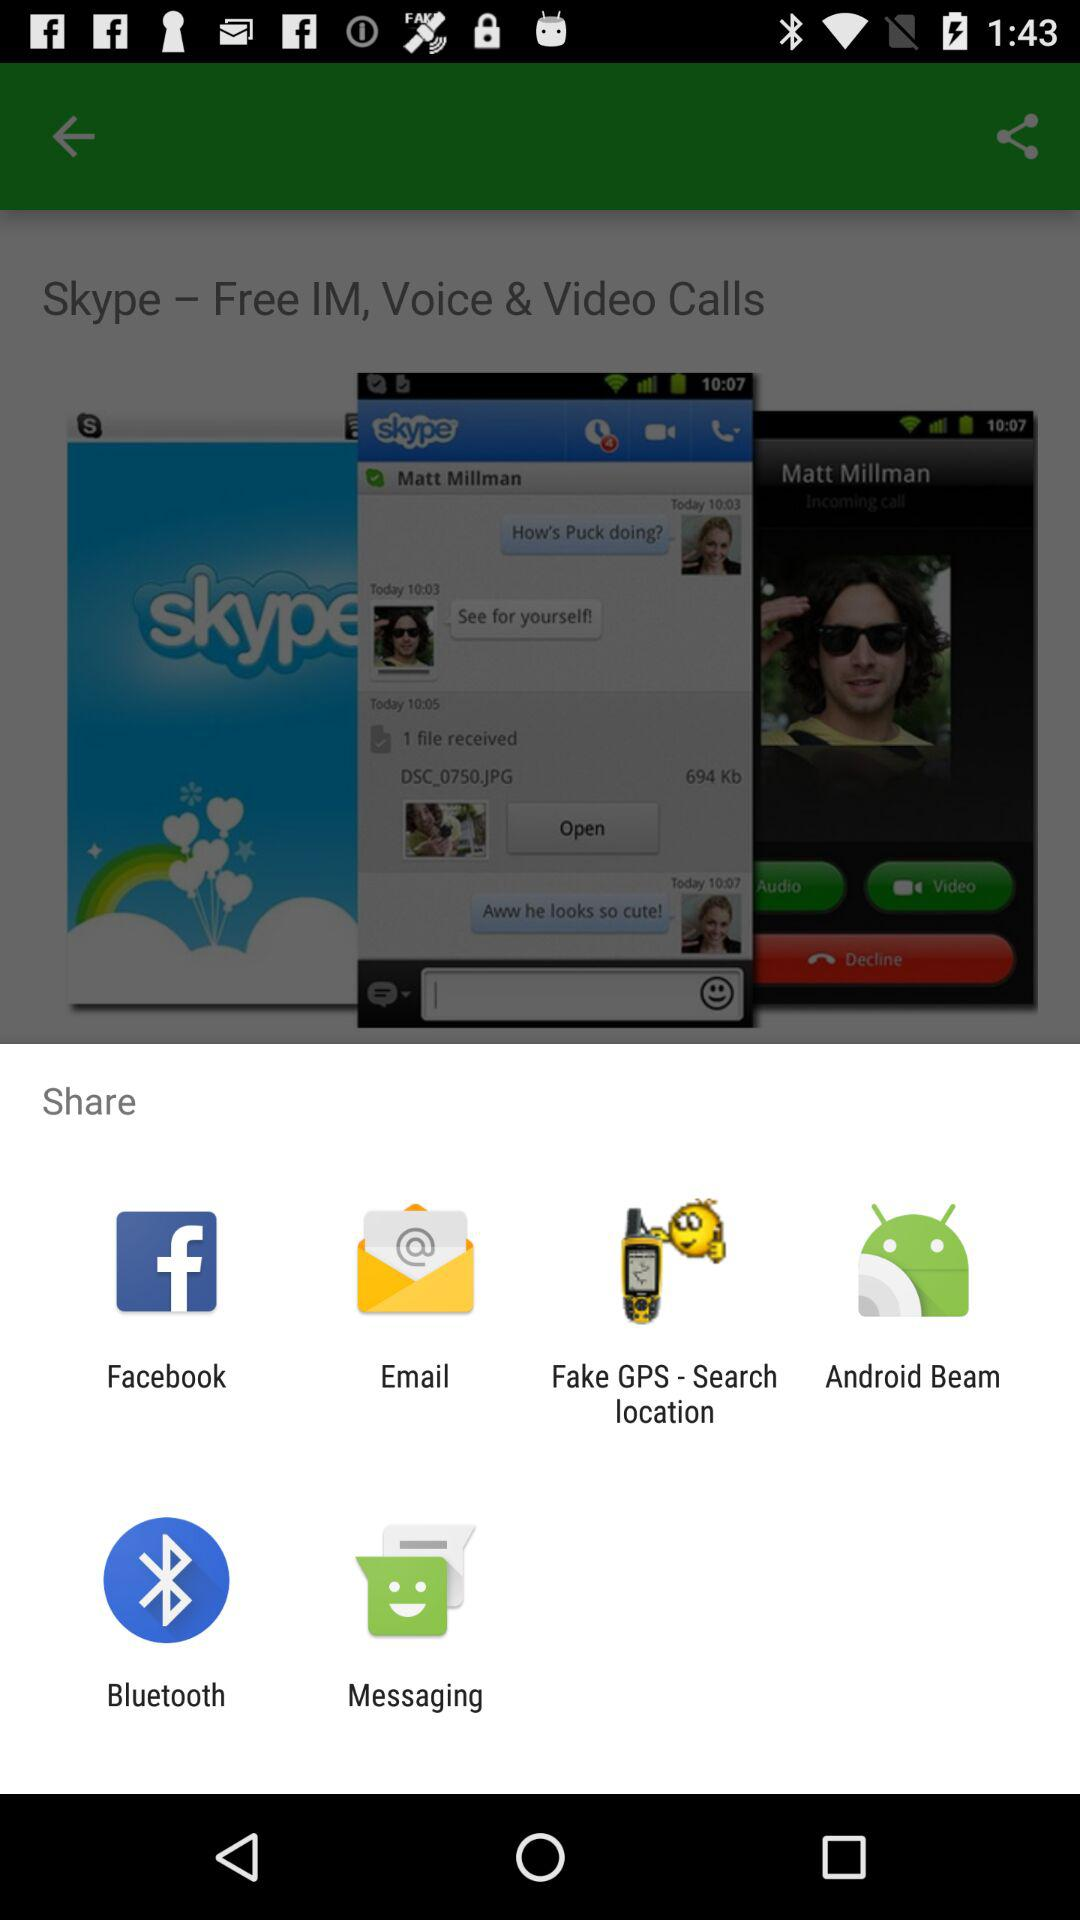How many items are displayed in the share menu?
Answer the question using a single word or phrase. 6 